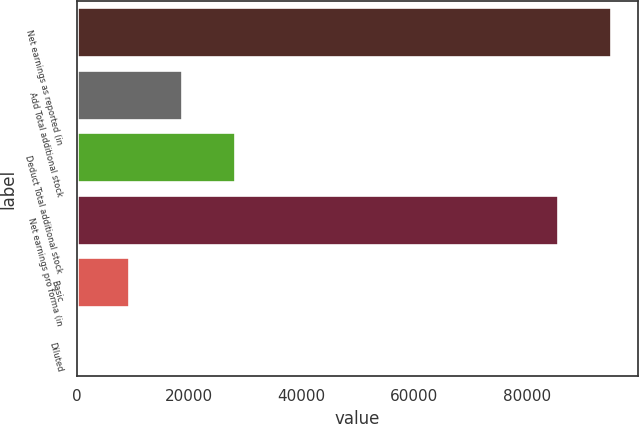<chart> <loc_0><loc_0><loc_500><loc_500><bar_chart><fcel>Net earnings as reported (in<fcel>Add Total additional stock<fcel>Deduct Total additional stock<fcel>Net earnings pro forma (in<fcel>Basic<fcel>Diluted<nl><fcel>95043.1<fcel>18771.4<fcel>28156.5<fcel>85658<fcel>9386.32<fcel>1.24<nl></chart> 